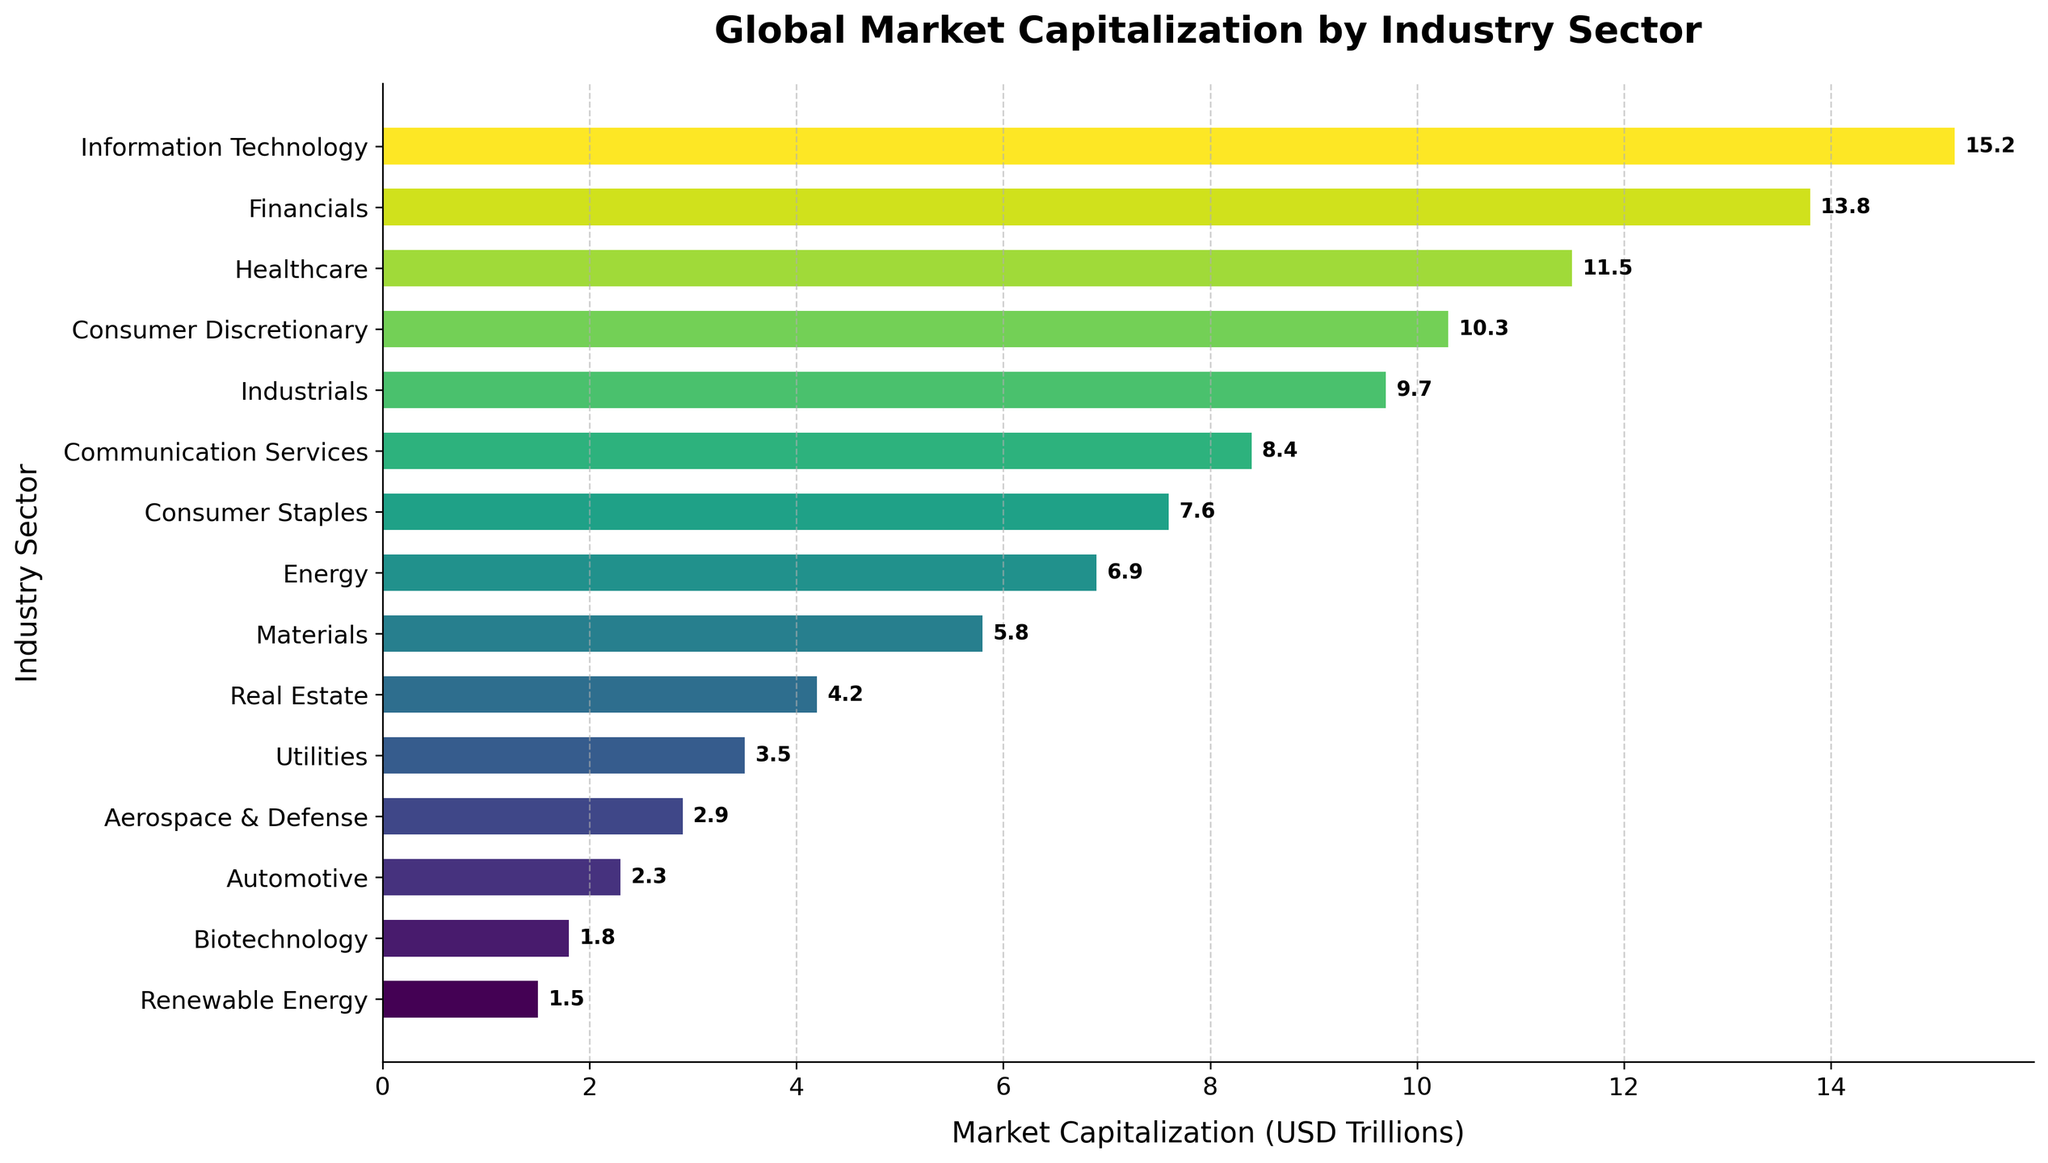Which industry sector has the highest market capitalization? Looking at the bar chart, the longest bar represents the industry sector with the highest market capitalization. The longest bar corresponds to Information Technology.
Answer: Information Technology How much more market capitalization does Information Technology have compared to Real Estate? From the chart, the market capitalization of Information Technology is 15.2 trillion USD, while Real Estate is 4.2 trillion USD. The difference is 15.2 - 4.2 = 11 trillion USD.
Answer: 11 trillion USD What are the three industry sectors with the lowest market capitalizations? The shortest bars in the chart represent the sectors with the lowest market capitalizations. These are Renewable Energy, Biotechnology, and Automotive.
Answer: Renewable Energy, Biotechnology, Automotive What is the total market capitalization of the top three industry sectors? The top three sectors by market capitalization are Information Technology (15.2 trillion USD), Financials (13.8 trillion USD), and Healthcare (11.5 trillion USD). Summing these gives 15.2 + 13.8 + 11.5 = 40.5 trillion USD.
Answer: 40.5 trillion USD Which sectors have a market capitalization greater than 10 trillion USD? From the chart, the sectors with bars longer than 10 trillion USD are Information Technology (15.2 trillion USD), Financials (13.8 trillion USD), Healthcare (11.5 trillion USD), and Consumer Discretionary (10.3 trillion USD).
Answer: Information Technology, Financials, Healthcare, Consumer Discretionary What is the average market capitalization of all shown industry sectors? Summing all the market capitalizations: 15.2 + 13.8 + 11.5 + 10.3 + 9.7 + 8.4 + 7.6 + 6.9 + 5.8 + 4.2 + 3.5 + 2.9 + 2.3 + 1.8 + 1.5 = 104.4 trillion USD. With 15 sectors, the average is 104.4 / 15 = 6.96 trillion USD.
Answer: 6.96 trillion USD What is the combined market capitalization of the Industrials and Energy sectors? From the chart, the market capitalization of Industrials is 9.7 trillion USD, and Energy is 6.9 trillion USD. The combined market capitalization is 9.7 + 6.9 = 16.6 trillion USD.
Answer: 16.6 trillion USD How many sectors have market capitalizations less than 5 trillion USD? From the chart, the sectors with capitalization less than 5 trillion USD are Real Estate, Utilities, Aerospace & Defense, Automotive, Biotechnology, and Renewable Energy, totaling six sectors.
Answer: 6 